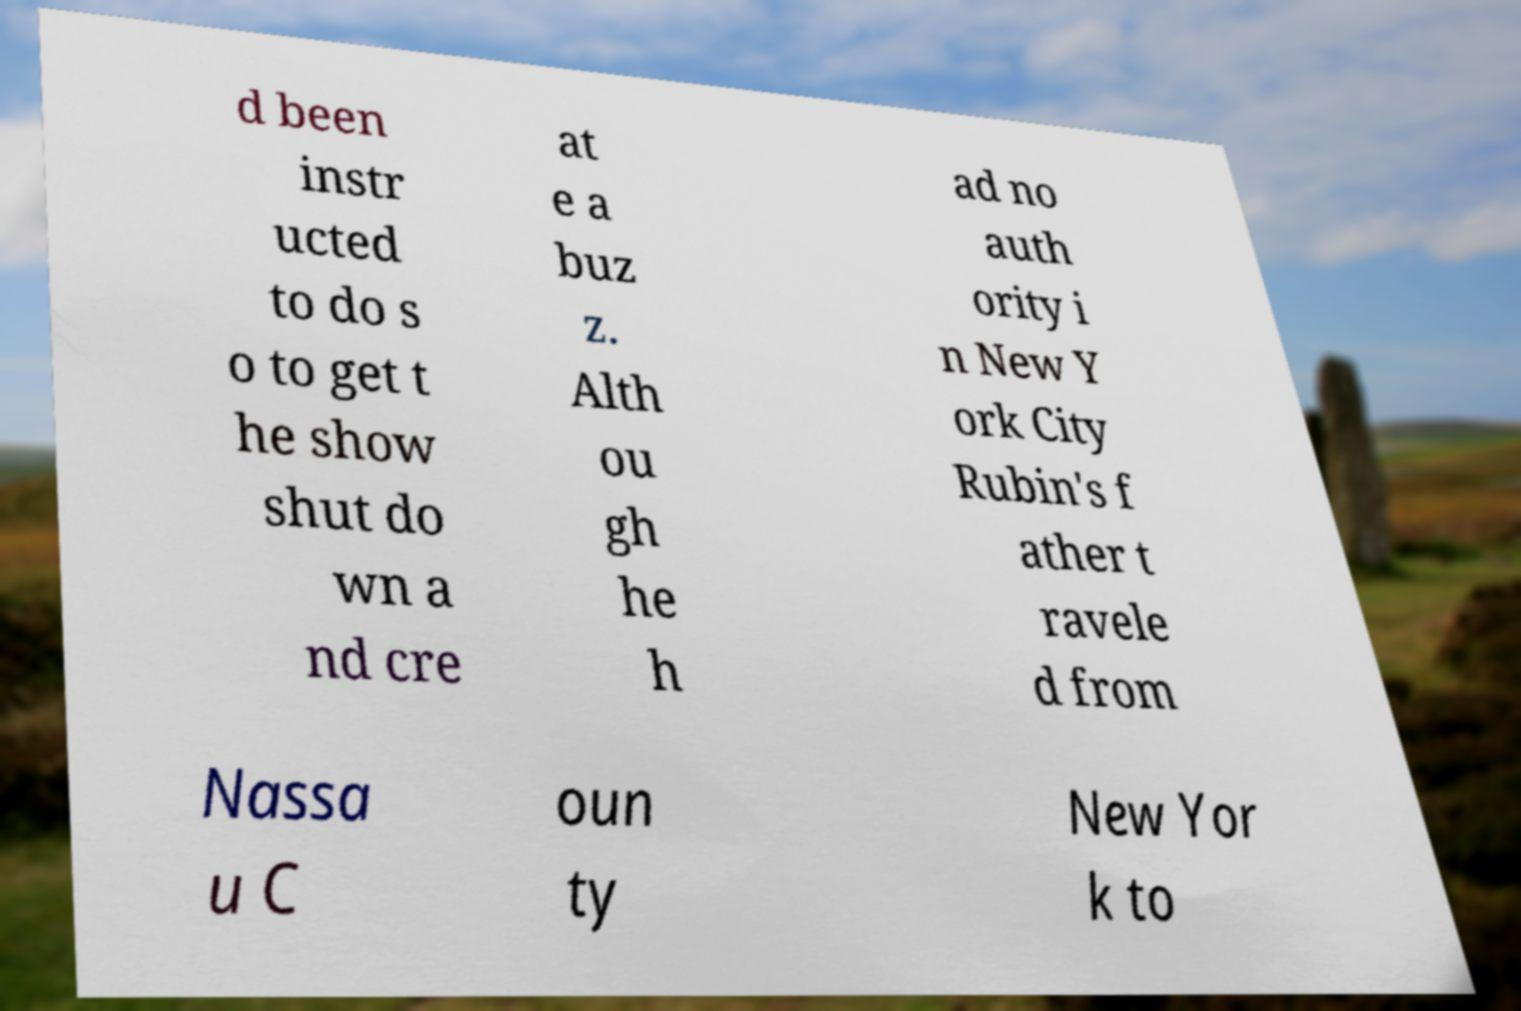Could you assist in decoding the text presented in this image and type it out clearly? d been instr ucted to do s o to get t he show shut do wn a nd cre at e a buz z. Alth ou gh he h ad no auth ority i n New Y ork City Rubin's f ather t ravele d from Nassa u C oun ty New Yor k to 